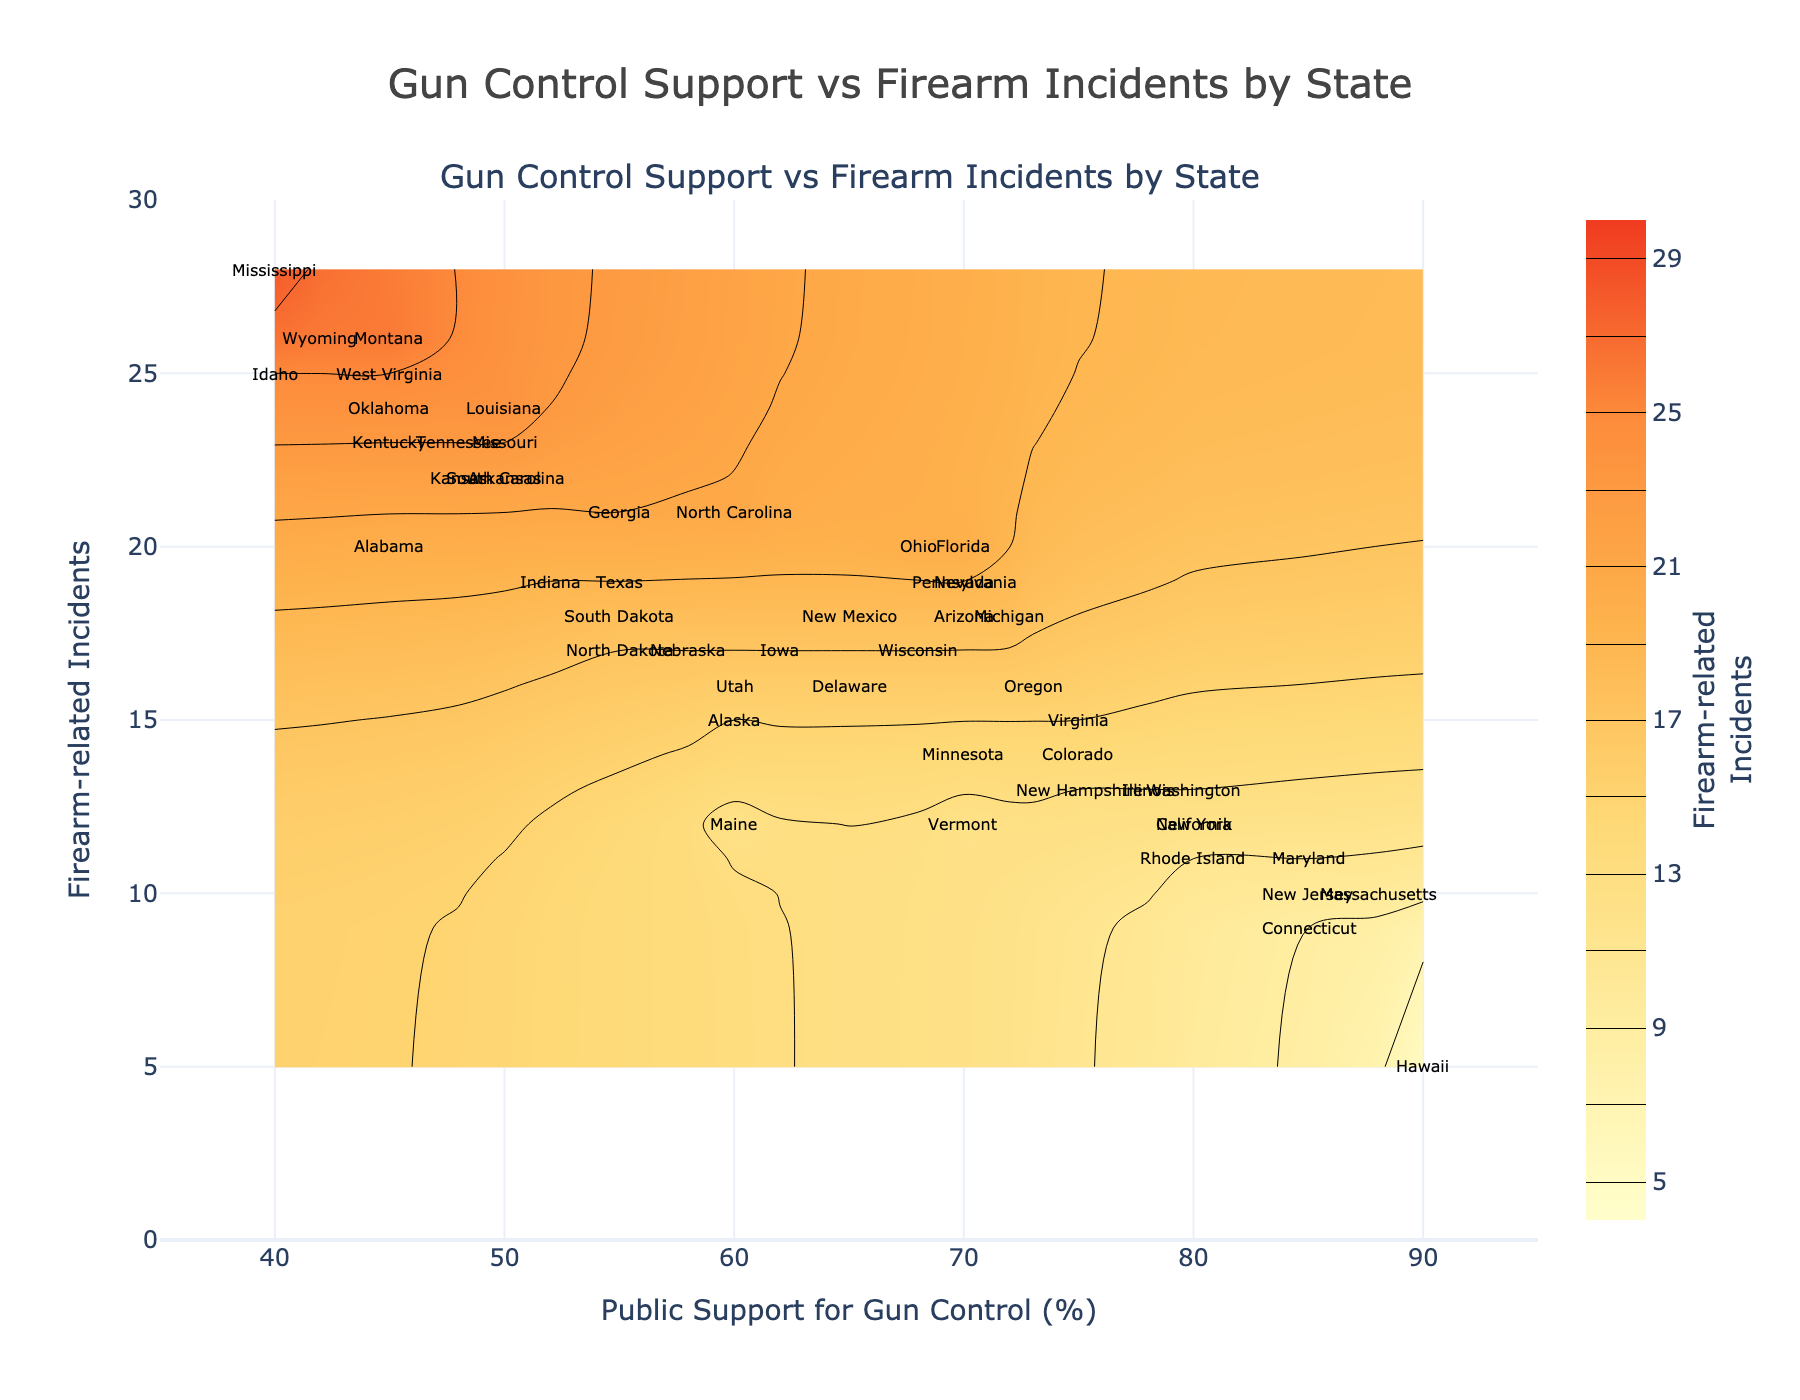What state exhibits the highest public support for gun control? Locate the state marker on the plot with the highest public support percentage on the x-axis, which is labeled as 90%. This corresponds to Hawaii.
Answer: Hawaii Which state shows the most firearm-related incidents? The state marker at the highest point on the y-axis, which reaches up to 28 incidents, corresponds to Mississippi.
Answer: Mississippi Compare states with equal public support for gun control: Alabama and Kansas. Which one has more firearm-related incidents? Identify the markers for both Alabama and Kansas on the plot. Despite having equal support of 45%, Alabama has 20 incidents while Kansas has 22.
Answer: Kansas How many states have public support for gun control at 55%? Count the number of state labels positioned at the 55% mark on the x-axis. These are Georgia, North Dakota, South Dakota, and Texas, totaling four states.
Answer: Four Is there any state with exactly 75% public support for gun control and the lowest firearm-related incidents? Among states with 75% support, we can check their incident rates on the y-axis. Virginia and Colorado have the lowest number of incidents, which is 14.
Answer: Virginia, Colorado What is the range of firearm-related incidents in states with 70% public support? Identify markers at the 70% x-axis position and note their y-axis incident values: Arizona (18), Florida (20), Michigan (18), Nevada (19), Pennsylvania (19), Vermont (12), Minnesota (14). The range is from 12 to 20 incidents.
Answer: 12 to 20 Which state has higher firearm-related incidents: Wyoming or Vermont? Look at the vertical position of these states on the plot. Wyoming (42% support) has 26 incidents, whereas Vermont (70% support) has 12 incidents, making Wyoming higher.
Answer: Wyoming Are there any states with at least 80% public support for gun control but less than or equal to 12 firearm-related incidents? Search for states at the x-axis of 80% or higher with incident values on the y-axis of 12 or fewer. These include California, New York, Rhode Island, Washington, and Connecticut.
Answer: California, New York, Rhode Island, Washington, Connecticut What is the average number of firearm-related incidents among states with public support between 50% and 60%? Identify these states: Arkansas, Louisiana, Georgia, Indiana, South Carolina, South Dakota, Texas, Utah, North Carolina, Vermont, Iowa, Nebraska, Delaware. Sum their incidents: 22+24+21+19+22+18+19+16+21+12+17+17+16=244. Divide by 13.
Answer: 18.77 (approximately) Which state at the lowest incident level on the plot also shows the highest public support for gun control? The state marker occupying the lowest position (5 incidents) has the leading support value on the x-axis, which is 90%, identified as Hawaii.
Answer: Hawaii 